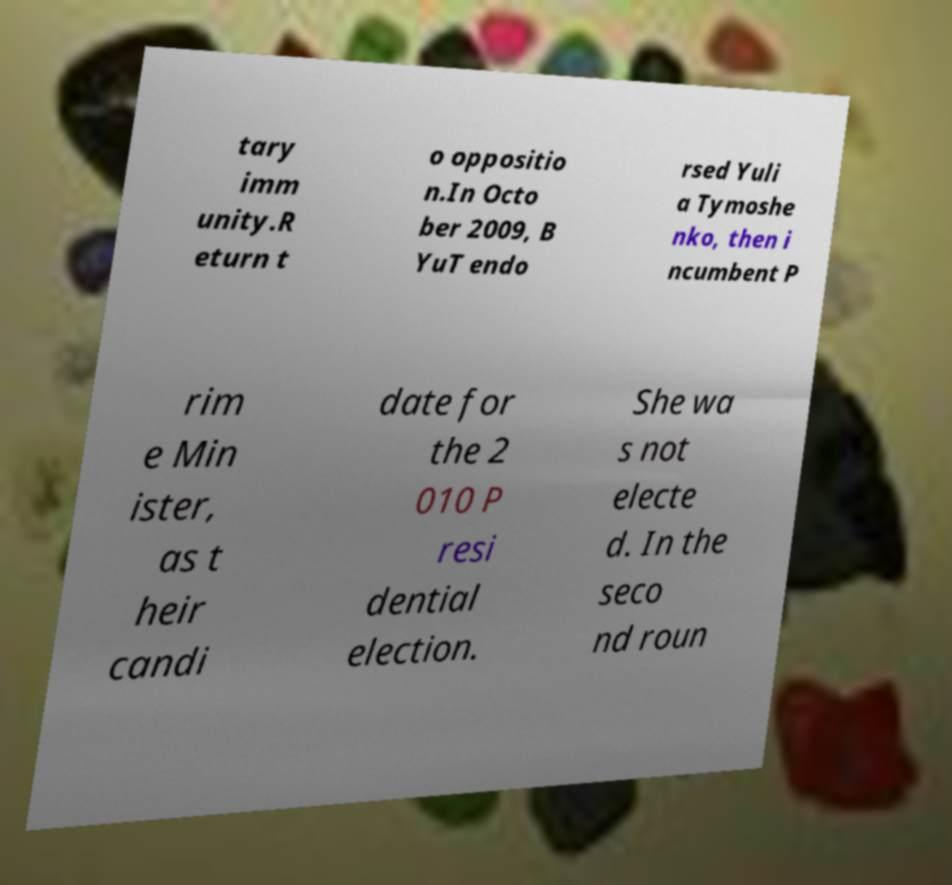Can you accurately transcribe the text from the provided image for me? tary imm unity.R eturn t o oppositio n.In Octo ber 2009, B YuT endo rsed Yuli a Tymoshe nko, then i ncumbent P rim e Min ister, as t heir candi date for the 2 010 P resi dential election. She wa s not electe d. In the seco nd roun 